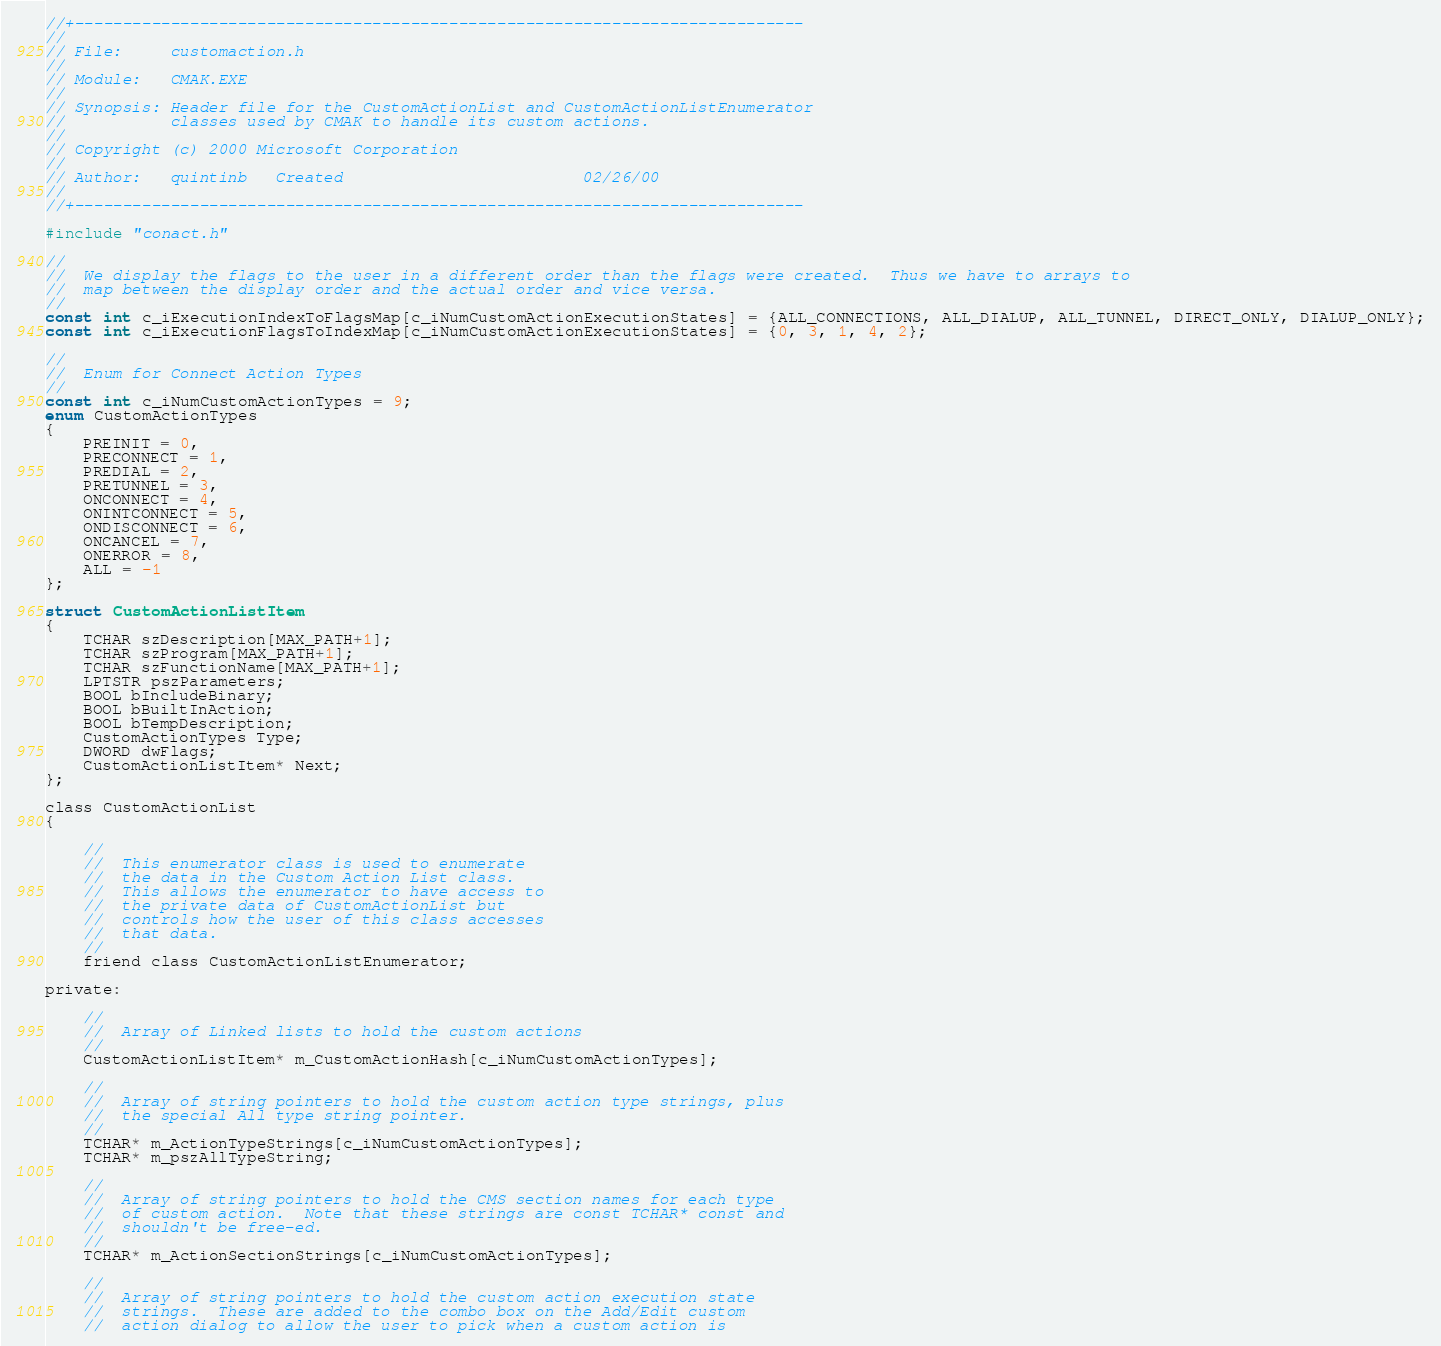<code> <loc_0><loc_0><loc_500><loc_500><_C_>//+----------------------------------------------------------------------------
//
// File:     customaction.h
//
// Module:   CMAK.EXE
//
// Synopsis: Header file for the CustomActionList and CustomActionListEnumerator
//           classes used by CMAK to handle its custom actions.
//
// Copyright (c) 2000 Microsoft Corporation
//
// Author:   quintinb   Created                         02/26/00
//
//+----------------------------------------------------------------------------

#include "conact.h"

//
//  We display the flags to the user in a different order than the flags were created.  Thus we have to arrays to
//  map between the display order and the actual order and vice versa.
//
const int c_iExecutionIndexToFlagsMap[c_iNumCustomActionExecutionStates] = {ALL_CONNECTIONS, ALL_DIALUP, ALL_TUNNEL, DIRECT_ONLY, DIALUP_ONLY};
const int c_iExecutionFlagsToIndexMap[c_iNumCustomActionExecutionStates] = {0, 3, 1, 4, 2};

//
//  Enum for Connect Action Types
//
const int c_iNumCustomActionTypes = 9;
enum CustomActionTypes
{
    PREINIT = 0,
    PRECONNECT = 1,
    PREDIAL = 2,
    PRETUNNEL = 3,
    ONCONNECT = 4,
    ONINTCONNECT = 5,
    ONDISCONNECT = 6,
    ONCANCEL = 7,
    ONERROR = 8,
    ALL = -1
};

struct CustomActionListItem
{
    TCHAR szDescription[MAX_PATH+1];
    TCHAR szProgram[MAX_PATH+1];
    TCHAR szFunctionName[MAX_PATH+1];
    LPTSTR pszParameters;
    BOOL bIncludeBinary;
    BOOL bBuiltInAction;
    BOOL bTempDescription;
    CustomActionTypes Type;
    DWORD dwFlags;
    CustomActionListItem* Next;
};

class CustomActionList
{

    //
    //  This enumerator class is used to enumerate
    //  the data in the Custom Action List class.
    //  This allows the enumerator to have access to
    //  the private data of CustomActionList but
    //  controls how the user of this class accesses
    //  that data.
    //
    friend class CustomActionListEnumerator;

private:

    //
    //  Array of Linked lists to hold the custom actions
    //
    CustomActionListItem* m_CustomActionHash[c_iNumCustomActionTypes];

    //
    //  Array of string pointers to hold the custom action type strings, plus
    //  the special All type string pointer.
    //
    TCHAR* m_ActionTypeStrings[c_iNumCustomActionTypes];
    TCHAR* m_pszAllTypeString;

    //
    //  Array of string pointers to hold the CMS section names for each type
    //  of custom action.  Note that these strings are const TCHAR* const and
    //  shouldn't be free-ed.
    //
    TCHAR* m_ActionSectionStrings[c_iNumCustomActionTypes];
    
    //
    //  Array of string pointers to hold the custom action execution state
    //  strings.  These are added to the combo box on the Add/Edit custom
    //  action dialog to allow the user to pick when a custom action is</code> 